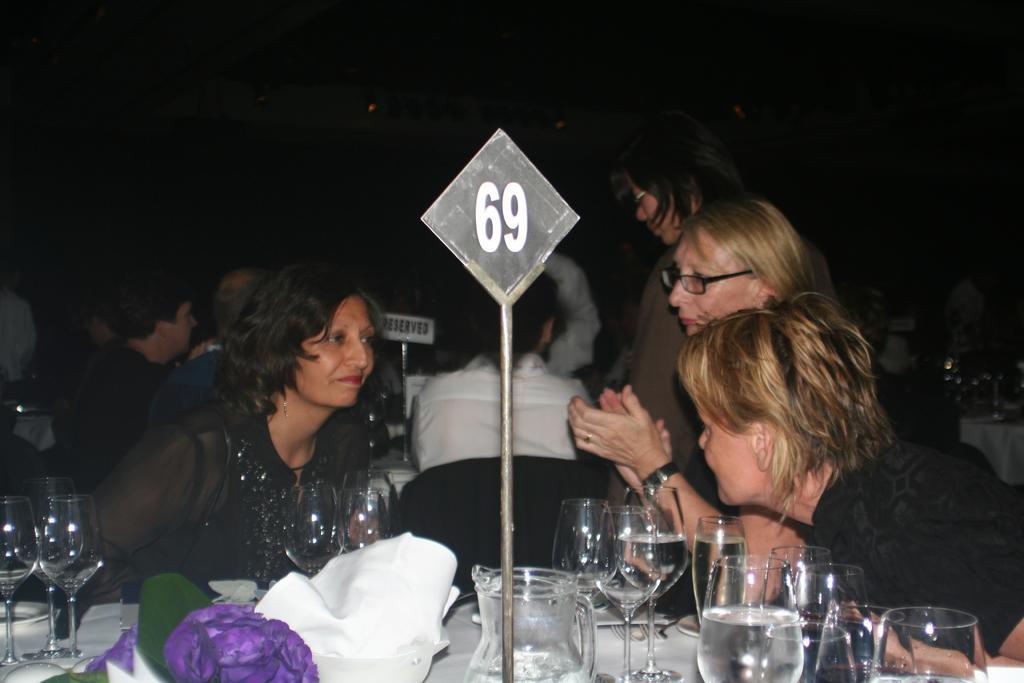Can you describe this image briefly? In this picture I can see there are few women sitting at the table and there are few men sitting at the table. There are glasses on the table. 